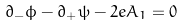<formula> <loc_0><loc_0><loc_500><loc_500>\partial _ { - } \phi - \partial _ { + } \psi - 2 e A _ { 1 } = 0</formula> 